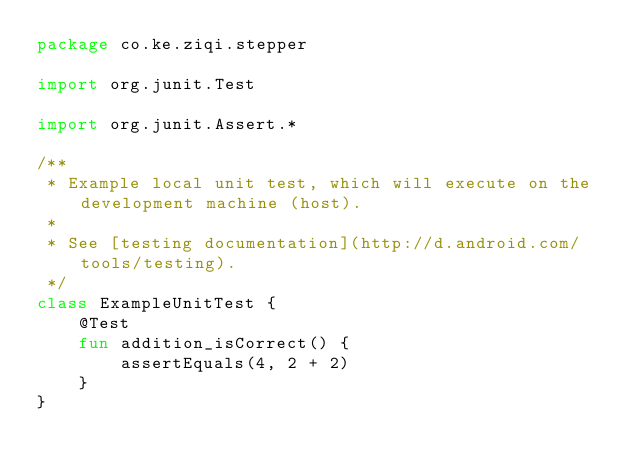<code> <loc_0><loc_0><loc_500><loc_500><_Kotlin_>package co.ke.ziqi.stepper

import org.junit.Test

import org.junit.Assert.*

/**
 * Example local unit test, which will execute on the development machine (host).
 *
 * See [testing documentation](http://d.android.com/tools/testing).
 */
class ExampleUnitTest {
    @Test
    fun addition_isCorrect() {
        assertEquals(4, 2 + 2)
    }
}
</code> 